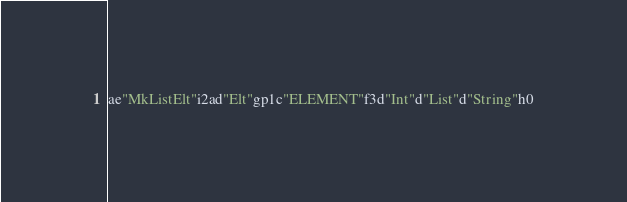Convert code to text. <code><loc_0><loc_0><loc_500><loc_500><_SML_>ae"MkListElt"i2ad"Elt"gp1c"ELEMENT"f3d"Int"d"List"d"String"h0</code> 